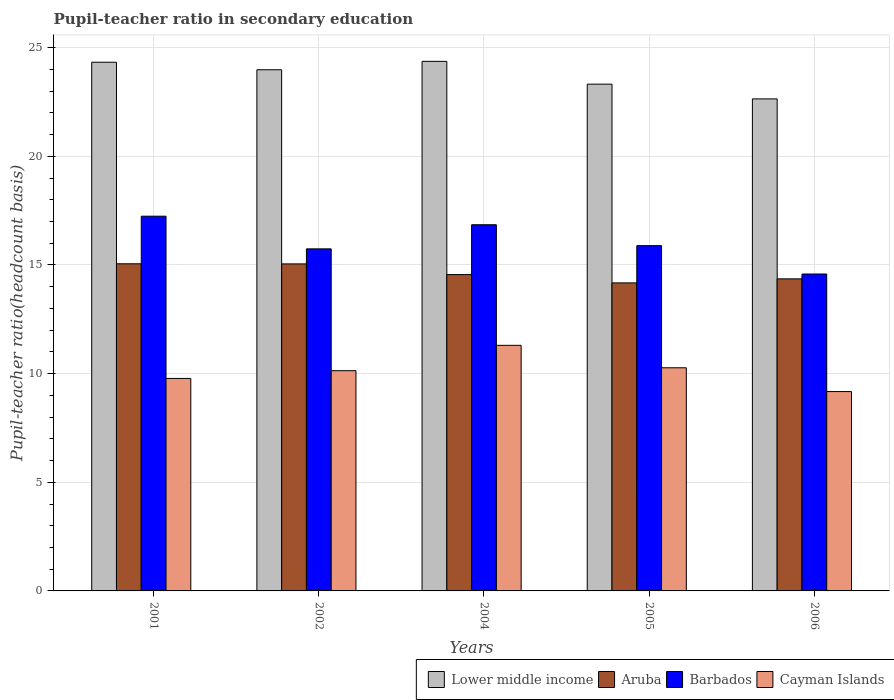How many groups of bars are there?
Keep it short and to the point. 5. Are the number of bars on each tick of the X-axis equal?
Offer a very short reply. Yes. How many bars are there on the 2nd tick from the left?
Make the answer very short. 4. What is the label of the 1st group of bars from the left?
Offer a very short reply. 2001. What is the pupil-teacher ratio in secondary education in Cayman Islands in 2006?
Keep it short and to the point. 9.17. Across all years, what is the maximum pupil-teacher ratio in secondary education in Cayman Islands?
Your response must be concise. 11.3. Across all years, what is the minimum pupil-teacher ratio in secondary education in Aruba?
Offer a very short reply. 14.18. In which year was the pupil-teacher ratio in secondary education in Cayman Islands minimum?
Offer a terse response. 2006. What is the total pupil-teacher ratio in secondary education in Aruba in the graph?
Make the answer very short. 73.2. What is the difference between the pupil-teacher ratio in secondary education in Barbados in 2001 and that in 2006?
Give a very brief answer. 2.66. What is the difference between the pupil-teacher ratio in secondary education in Lower middle income in 2005 and the pupil-teacher ratio in secondary education in Barbados in 2001?
Provide a succinct answer. 6.08. What is the average pupil-teacher ratio in secondary education in Aruba per year?
Your answer should be very brief. 14.64. In the year 2001, what is the difference between the pupil-teacher ratio in secondary education in Cayman Islands and pupil-teacher ratio in secondary education in Barbados?
Ensure brevity in your answer.  -7.47. In how many years, is the pupil-teacher ratio in secondary education in Cayman Islands greater than 15?
Your answer should be very brief. 0. What is the ratio of the pupil-teacher ratio in secondary education in Aruba in 2002 to that in 2006?
Offer a terse response. 1.05. Is the pupil-teacher ratio in secondary education in Aruba in 2004 less than that in 2005?
Ensure brevity in your answer.  No. Is the difference between the pupil-teacher ratio in secondary education in Cayman Islands in 2001 and 2004 greater than the difference between the pupil-teacher ratio in secondary education in Barbados in 2001 and 2004?
Keep it short and to the point. No. What is the difference between the highest and the second highest pupil-teacher ratio in secondary education in Barbados?
Make the answer very short. 0.39. What is the difference between the highest and the lowest pupil-teacher ratio in secondary education in Aruba?
Provide a short and direct response. 0.88. In how many years, is the pupil-teacher ratio in secondary education in Barbados greater than the average pupil-teacher ratio in secondary education in Barbados taken over all years?
Give a very brief answer. 2. Is the sum of the pupil-teacher ratio in secondary education in Aruba in 2001 and 2002 greater than the maximum pupil-teacher ratio in secondary education in Cayman Islands across all years?
Ensure brevity in your answer.  Yes. Is it the case that in every year, the sum of the pupil-teacher ratio in secondary education in Aruba and pupil-teacher ratio in secondary education in Cayman Islands is greater than the sum of pupil-teacher ratio in secondary education in Lower middle income and pupil-teacher ratio in secondary education in Barbados?
Your answer should be compact. No. What does the 3rd bar from the left in 2002 represents?
Ensure brevity in your answer.  Barbados. What does the 3rd bar from the right in 2001 represents?
Make the answer very short. Aruba. Is it the case that in every year, the sum of the pupil-teacher ratio in secondary education in Lower middle income and pupil-teacher ratio in secondary education in Cayman Islands is greater than the pupil-teacher ratio in secondary education in Aruba?
Your response must be concise. Yes. Are all the bars in the graph horizontal?
Your answer should be very brief. No. What is the difference between two consecutive major ticks on the Y-axis?
Offer a terse response. 5. Does the graph contain any zero values?
Provide a succinct answer. No. Does the graph contain grids?
Offer a very short reply. Yes. How many legend labels are there?
Make the answer very short. 4. What is the title of the graph?
Your answer should be very brief. Pupil-teacher ratio in secondary education. What is the label or title of the Y-axis?
Make the answer very short. Pupil-teacher ratio(headcount basis). What is the Pupil-teacher ratio(headcount basis) in Lower middle income in 2001?
Your answer should be compact. 24.33. What is the Pupil-teacher ratio(headcount basis) of Aruba in 2001?
Keep it short and to the point. 15.05. What is the Pupil-teacher ratio(headcount basis) of Barbados in 2001?
Provide a short and direct response. 17.24. What is the Pupil-teacher ratio(headcount basis) in Cayman Islands in 2001?
Offer a very short reply. 9.78. What is the Pupil-teacher ratio(headcount basis) in Lower middle income in 2002?
Provide a short and direct response. 23.98. What is the Pupil-teacher ratio(headcount basis) of Aruba in 2002?
Give a very brief answer. 15.05. What is the Pupil-teacher ratio(headcount basis) in Barbados in 2002?
Give a very brief answer. 15.74. What is the Pupil-teacher ratio(headcount basis) in Cayman Islands in 2002?
Give a very brief answer. 10.13. What is the Pupil-teacher ratio(headcount basis) of Lower middle income in 2004?
Offer a terse response. 24.37. What is the Pupil-teacher ratio(headcount basis) of Aruba in 2004?
Your answer should be very brief. 14.56. What is the Pupil-teacher ratio(headcount basis) in Barbados in 2004?
Ensure brevity in your answer.  16.85. What is the Pupil-teacher ratio(headcount basis) of Cayman Islands in 2004?
Your response must be concise. 11.3. What is the Pupil-teacher ratio(headcount basis) of Lower middle income in 2005?
Keep it short and to the point. 23.32. What is the Pupil-teacher ratio(headcount basis) of Aruba in 2005?
Give a very brief answer. 14.18. What is the Pupil-teacher ratio(headcount basis) of Barbados in 2005?
Your answer should be very brief. 15.89. What is the Pupil-teacher ratio(headcount basis) of Cayman Islands in 2005?
Provide a succinct answer. 10.27. What is the Pupil-teacher ratio(headcount basis) of Lower middle income in 2006?
Offer a terse response. 22.64. What is the Pupil-teacher ratio(headcount basis) of Aruba in 2006?
Your answer should be compact. 14.36. What is the Pupil-teacher ratio(headcount basis) in Barbados in 2006?
Give a very brief answer. 14.58. What is the Pupil-teacher ratio(headcount basis) in Cayman Islands in 2006?
Provide a short and direct response. 9.17. Across all years, what is the maximum Pupil-teacher ratio(headcount basis) in Lower middle income?
Your answer should be very brief. 24.37. Across all years, what is the maximum Pupil-teacher ratio(headcount basis) in Aruba?
Your answer should be compact. 15.05. Across all years, what is the maximum Pupil-teacher ratio(headcount basis) of Barbados?
Make the answer very short. 17.24. Across all years, what is the maximum Pupil-teacher ratio(headcount basis) of Cayman Islands?
Ensure brevity in your answer.  11.3. Across all years, what is the minimum Pupil-teacher ratio(headcount basis) in Lower middle income?
Offer a very short reply. 22.64. Across all years, what is the minimum Pupil-teacher ratio(headcount basis) of Aruba?
Provide a succinct answer. 14.18. Across all years, what is the minimum Pupil-teacher ratio(headcount basis) in Barbados?
Offer a terse response. 14.58. Across all years, what is the minimum Pupil-teacher ratio(headcount basis) of Cayman Islands?
Make the answer very short. 9.17. What is the total Pupil-teacher ratio(headcount basis) of Lower middle income in the graph?
Provide a succinct answer. 118.65. What is the total Pupil-teacher ratio(headcount basis) in Aruba in the graph?
Ensure brevity in your answer.  73.2. What is the total Pupil-teacher ratio(headcount basis) of Barbados in the graph?
Provide a short and direct response. 80.31. What is the total Pupil-teacher ratio(headcount basis) in Cayman Islands in the graph?
Provide a succinct answer. 50.66. What is the difference between the Pupil-teacher ratio(headcount basis) in Lower middle income in 2001 and that in 2002?
Give a very brief answer. 0.35. What is the difference between the Pupil-teacher ratio(headcount basis) of Aruba in 2001 and that in 2002?
Offer a very short reply. 0. What is the difference between the Pupil-teacher ratio(headcount basis) in Barbados in 2001 and that in 2002?
Make the answer very short. 1.5. What is the difference between the Pupil-teacher ratio(headcount basis) of Cayman Islands in 2001 and that in 2002?
Your response must be concise. -0.36. What is the difference between the Pupil-teacher ratio(headcount basis) in Lower middle income in 2001 and that in 2004?
Your response must be concise. -0.04. What is the difference between the Pupil-teacher ratio(headcount basis) in Aruba in 2001 and that in 2004?
Provide a succinct answer. 0.5. What is the difference between the Pupil-teacher ratio(headcount basis) of Barbados in 2001 and that in 2004?
Your answer should be very brief. 0.39. What is the difference between the Pupil-teacher ratio(headcount basis) in Cayman Islands in 2001 and that in 2004?
Keep it short and to the point. -1.52. What is the difference between the Pupil-teacher ratio(headcount basis) of Lower middle income in 2001 and that in 2005?
Make the answer very short. 1.01. What is the difference between the Pupil-teacher ratio(headcount basis) in Aruba in 2001 and that in 2005?
Your response must be concise. 0.88. What is the difference between the Pupil-teacher ratio(headcount basis) of Barbados in 2001 and that in 2005?
Your response must be concise. 1.36. What is the difference between the Pupil-teacher ratio(headcount basis) of Cayman Islands in 2001 and that in 2005?
Provide a succinct answer. -0.49. What is the difference between the Pupil-teacher ratio(headcount basis) in Lower middle income in 2001 and that in 2006?
Your response must be concise. 1.69. What is the difference between the Pupil-teacher ratio(headcount basis) in Aruba in 2001 and that in 2006?
Give a very brief answer. 0.69. What is the difference between the Pupil-teacher ratio(headcount basis) in Barbados in 2001 and that in 2006?
Your answer should be very brief. 2.66. What is the difference between the Pupil-teacher ratio(headcount basis) in Cayman Islands in 2001 and that in 2006?
Give a very brief answer. 0.6. What is the difference between the Pupil-teacher ratio(headcount basis) of Lower middle income in 2002 and that in 2004?
Ensure brevity in your answer.  -0.39. What is the difference between the Pupil-teacher ratio(headcount basis) in Aruba in 2002 and that in 2004?
Keep it short and to the point. 0.49. What is the difference between the Pupil-teacher ratio(headcount basis) in Barbados in 2002 and that in 2004?
Make the answer very short. -1.11. What is the difference between the Pupil-teacher ratio(headcount basis) in Cayman Islands in 2002 and that in 2004?
Your answer should be very brief. -1.17. What is the difference between the Pupil-teacher ratio(headcount basis) of Lower middle income in 2002 and that in 2005?
Your answer should be compact. 0.66. What is the difference between the Pupil-teacher ratio(headcount basis) of Aruba in 2002 and that in 2005?
Offer a very short reply. 0.87. What is the difference between the Pupil-teacher ratio(headcount basis) of Barbados in 2002 and that in 2005?
Ensure brevity in your answer.  -0.15. What is the difference between the Pupil-teacher ratio(headcount basis) in Cayman Islands in 2002 and that in 2005?
Make the answer very short. -0.13. What is the difference between the Pupil-teacher ratio(headcount basis) of Lower middle income in 2002 and that in 2006?
Your answer should be very brief. 1.34. What is the difference between the Pupil-teacher ratio(headcount basis) of Aruba in 2002 and that in 2006?
Your answer should be very brief. 0.69. What is the difference between the Pupil-teacher ratio(headcount basis) of Barbados in 2002 and that in 2006?
Offer a very short reply. 1.16. What is the difference between the Pupil-teacher ratio(headcount basis) in Cayman Islands in 2002 and that in 2006?
Give a very brief answer. 0.96. What is the difference between the Pupil-teacher ratio(headcount basis) in Lower middle income in 2004 and that in 2005?
Your response must be concise. 1.05. What is the difference between the Pupil-teacher ratio(headcount basis) of Aruba in 2004 and that in 2005?
Keep it short and to the point. 0.38. What is the difference between the Pupil-teacher ratio(headcount basis) of Barbados in 2004 and that in 2005?
Offer a very short reply. 0.96. What is the difference between the Pupil-teacher ratio(headcount basis) in Cayman Islands in 2004 and that in 2005?
Your response must be concise. 1.03. What is the difference between the Pupil-teacher ratio(headcount basis) of Lower middle income in 2004 and that in 2006?
Give a very brief answer. 1.73. What is the difference between the Pupil-teacher ratio(headcount basis) of Aruba in 2004 and that in 2006?
Provide a succinct answer. 0.2. What is the difference between the Pupil-teacher ratio(headcount basis) of Barbados in 2004 and that in 2006?
Give a very brief answer. 2.27. What is the difference between the Pupil-teacher ratio(headcount basis) in Cayman Islands in 2004 and that in 2006?
Your response must be concise. 2.13. What is the difference between the Pupil-teacher ratio(headcount basis) in Lower middle income in 2005 and that in 2006?
Offer a terse response. 0.68. What is the difference between the Pupil-teacher ratio(headcount basis) in Aruba in 2005 and that in 2006?
Make the answer very short. -0.19. What is the difference between the Pupil-teacher ratio(headcount basis) of Barbados in 2005 and that in 2006?
Offer a terse response. 1.3. What is the difference between the Pupil-teacher ratio(headcount basis) of Cayman Islands in 2005 and that in 2006?
Give a very brief answer. 1.09. What is the difference between the Pupil-teacher ratio(headcount basis) in Lower middle income in 2001 and the Pupil-teacher ratio(headcount basis) in Aruba in 2002?
Provide a short and direct response. 9.28. What is the difference between the Pupil-teacher ratio(headcount basis) of Lower middle income in 2001 and the Pupil-teacher ratio(headcount basis) of Barbados in 2002?
Your response must be concise. 8.59. What is the difference between the Pupil-teacher ratio(headcount basis) in Lower middle income in 2001 and the Pupil-teacher ratio(headcount basis) in Cayman Islands in 2002?
Provide a short and direct response. 14.2. What is the difference between the Pupil-teacher ratio(headcount basis) in Aruba in 2001 and the Pupil-teacher ratio(headcount basis) in Barbados in 2002?
Offer a very short reply. -0.69. What is the difference between the Pupil-teacher ratio(headcount basis) of Aruba in 2001 and the Pupil-teacher ratio(headcount basis) of Cayman Islands in 2002?
Keep it short and to the point. 4.92. What is the difference between the Pupil-teacher ratio(headcount basis) in Barbados in 2001 and the Pupil-teacher ratio(headcount basis) in Cayman Islands in 2002?
Ensure brevity in your answer.  7.11. What is the difference between the Pupil-teacher ratio(headcount basis) in Lower middle income in 2001 and the Pupil-teacher ratio(headcount basis) in Aruba in 2004?
Offer a very short reply. 9.77. What is the difference between the Pupil-teacher ratio(headcount basis) of Lower middle income in 2001 and the Pupil-teacher ratio(headcount basis) of Barbados in 2004?
Your response must be concise. 7.48. What is the difference between the Pupil-teacher ratio(headcount basis) of Lower middle income in 2001 and the Pupil-teacher ratio(headcount basis) of Cayman Islands in 2004?
Your answer should be compact. 13.03. What is the difference between the Pupil-teacher ratio(headcount basis) of Aruba in 2001 and the Pupil-teacher ratio(headcount basis) of Barbados in 2004?
Offer a terse response. -1.8. What is the difference between the Pupil-teacher ratio(headcount basis) in Aruba in 2001 and the Pupil-teacher ratio(headcount basis) in Cayman Islands in 2004?
Provide a succinct answer. 3.75. What is the difference between the Pupil-teacher ratio(headcount basis) of Barbados in 2001 and the Pupil-teacher ratio(headcount basis) of Cayman Islands in 2004?
Your answer should be very brief. 5.94. What is the difference between the Pupil-teacher ratio(headcount basis) of Lower middle income in 2001 and the Pupil-teacher ratio(headcount basis) of Aruba in 2005?
Offer a terse response. 10.15. What is the difference between the Pupil-teacher ratio(headcount basis) of Lower middle income in 2001 and the Pupil-teacher ratio(headcount basis) of Barbados in 2005?
Ensure brevity in your answer.  8.44. What is the difference between the Pupil-teacher ratio(headcount basis) of Lower middle income in 2001 and the Pupil-teacher ratio(headcount basis) of Cayman Islands in 2005?
Your response must be concise. 14.06. What is the difference between the Pupil-teacher ratio(headcount basis) in Aruba in 2001 and the Pupil-teacher ratio(headcount basis) in Barbados in 2005?
Provide a short and direct response. -0.83. What is the difference between the Pupil-teacher ratio(headcount basis) in Aruba in 2001 and the Pupil-teacher ratio(headcount basis) in Cayman Islands in 2005?
Offer a very short reply. 4.78. What is the difference between the Pupil-teacher ratio(headcount basis) in Barbados in 2001 and the Pupil-teacher ratio(headcount basis) in Cayman Islands in 2005?
Your response must be concise. 6.98. What is the difference between the Pupil-teacher ratio(headcount basis) of Lower middle income in 2001 and the Pupil-teacher ratio(headcount basis) of Aruba in 2006?
Offer a terse response. 9.97. What is the difference between the Pupil-teacher ratio(headcount basis) of Lower middle income in 2001 and the Pupil-teacher ratio(headcount basis) of Barbados in 2006?
Ensure brevity in your answer.  9.75. What is the difference between the Pupil-teacher ratio(headcount basis) in Lower middle income in 2001 and the Pupil-teacher ratio(headcount basis) in Cayman Islands in 2006?
Provide a succinct answer. 15.16. What is the difference between the Pupil-teacher ratio(headcount basis) of Aruba in 2001 and the Pupil-teacher ratio(headcount basis) of Barbados in 2006?
Keep it short and to the point. 0.47. What is the difference between the Pupil-teacher ratio(headcount basis) of Aruba in 2001 and the Pupil-teacher ratio(headcount basis) of Cayman Islands in 2006?
Make the answer very short. 5.88. What is the difference between the Pupil-teacher ratio(headcount basis) in Barbados in 2001 and the Pupil-teacher ratio(headcount basis) in Cayman Islands in 2006?
Provide a succinct answer. 8.07. What is the difference between the Pupil-teacher ratio(headcount basis) of Lower middle income in 2002 and the Pupil-teacher ratio(headcount basis) of Aruba in 2004?
Give a very brief answer. 9.43. What is the difference between the Pupil-teacher ratio(headcount basis) in Lower middle income in 2002 and the Pupil-teacher ratio(headcount basis) in Barbados in 2004?
Your answer should be compact. 7.13. What is the difference between the Pupil-teacher ratio(headcount basis) in Lower middle income in 2002 and the Pupil-teacher ratio(headcount basis) in Cayman Islands in 2004?
Provide a short and direct response. 12.68. What is the difference between the Pupil-teacher ratio(headcount basis) of Aruba in 2002 and the Pupil-teacher ratio(headcount basis) of Barbados in 2004?
Give a very brief answer. -1.8. What is the difference between the Pupil-teacher ratio(headcount basis) in Aruba in 2002 and the Pupil-teacher ratio(headcount basis) in Cayman Islands in 2004?
Your response must be concise. 3.75. What is the difference between the Pupil-teacher ratio(headcount basis) of Barbados in 2002 and the Pupil-teacher ratio(headcount basis) of Cayman Islands in 2004?
Ensure brevity in your answer.  4.44. What is the difference between the Pupil-teacher ratio(headcount basis) of Lower middle income in 2002 and the Pupil-teacher ratio(headcount basis) of Aruba in 2005?
Your response must be concise. 9.81. What is the difference between the Pupil-teacher ratio(headcount basis) in Lower middle income in 2002 and the Pupil-teacher ratio(headcount basis) in Barbados in 2005?
Your response must be concise. 8.09. What is the difference between the Pupil-teacher ratio(headcount basis) in Lower middle income in 2002 and the Pupil-teacher ratio(headcount basis) in Cayman Islands in 2005?
Provide a succinct answer. 13.71. What is the difference between the Pupil-teacher ratio(headcount basis) of Aruba in 2002 and the Pupil-teacher ratio(headcount basis) of Barbados in 2005?
Your answer should be very brief. -0.84. What is the difference between the Pupil-teacher ratio(headcount basis) of Aruba in 2002 and the Pupil-teacher ratio(headcount basis) of Cayman Islands in 2005?
Offer a terse response. 4.78. What is the difference between the Pupil-teacher ratio(headcount basis) of Barbados in 2002 and the Pupil-teacher ratio(headcount basis) of Cayman Islands in 2005?
Keep it short and to the point. 5.47. What is the difference between the Pupil-teacher ratio(headcount basis) in Lower middle income in 2002 and the Pupil-teacher ratio(headcount basis) in Aruba in 2006?
Your response must be concise. 9.62. What is the difference between the Pupil-teacher ratio(headcount basis) of Lower middle income in 2002 and the Pupil-teacher ratio(headcount basis) of Barbados in 2006?
Offer a very short reply. 9.4. What is the difference between the Pupil-teacher ratio(headcount basis) of Lower middle income in 2002 and the Pupil-teacher ratio(headcount basis) of Cayman Islands in 2006?
Your response must be concise. 14.81. What is the difference between the Pupil-teacher ratio(headcount basis) in Aruba in 2002 and the Pupil-teacher ratio(headcount basis) in Barbados in 2006?
Keep it short and to the point. 0.47. What is the difference between the Pupil-teacher ratio(headcount basis) in Aruba in 2002 and the Pupil-teacher ratio(headcount basis) in Cayman Islands in 2006?
Your answer should be compact. 5.87. What is the difference between the Pupil-teacher ratio(headcount basis) in Barbados in 2002 and the Pupil-teacher ratio(headcount basis) in Cayman Islands in 2006?
Your response must be concise. 6.57. What is the difference between the Pupil-teacher ratio(headcount basis) of Lower middle income in 2004 and the Pupil-teacher ratio(headcount basis) of Aruba in 2005?
Ensure brevity in your answer.  10.19. What is the difference between the Pupil-teacher ratio(headcount basis) in Lower middle income in 2004 and the Pupil-teacher ratio(headcount basis) in Barbados in 2005?
Keep it short and to the point. 8.48. What is the difference between the Pupil-teacher ratio(headcount basis) in Lower middle income in 2004 and the Pupil-teacher ratio(headcount basis) in Cayman Islands in 2005?
Give a very brief answer. 14.1. What is the difference between the Pupil-teacher ratio(headcount basis) of Aruba in 2004 and the Pupil-teacher ratio(headcount basis) of Barbados in 2005?
Provide a succinct answer. -1.33. What is the difference between the Pupil-teacher ratio(headcount basis) in Aruba in 2004 and the Pupil-teacher ratio(headcount basis) in Cayman Islands in 2005?
Keep it short and to the point. 4.29. What is the difference between the Pupil-teacher ratio(headcount basis) in Barbados in 2004 and the Pupil-teacher ratio(headcount basis) in Cayman Islands in 2005?
Provide a succinct answer. 6.58. What is the difference between the Pupil-teacher ratio(headcount basis) in Lower middle income in 2004 and the Pupil-teacher ratio(headcount basis) in Aruba in 2006?
Your answer should be very brief. 10.01. What is the difference between the Pupil-teacher ratio(headcount basis) of Lower middle income in 2004 and the Pupil-teacher ratio(headcount basis) of Barbados in 2006?
Provide a short and direct response. 9.79. What is the difference between the Pupil-teacher ratio(headcount basis) in Lower middle income in 2004 and the Pupil-teacher ratio(headcount basis) in Cayman Islands in 2006?
Offer a very short reply. 15.2. What is the difference between the Pupil-teacher ratio(headcount basis) of Aruba in 2004 and the Pupil-teacher ratio(headcount basis) of Barbados in 2006?
Your response must be concise. -0.03. What is the difference between the Pupil-teacher ratio(headcount basis) in Aruba in 2004 and the Pupil-teacher ratio(headcount basis) in Cayman Islands in 2006?
Offer a terse response. 5.38. What is the difference between the Pupil-teacher ratio(headcount basis) in Barbados in 2004 and the Pupil-teacher ratio(headcount basis) in Cayman Islands in 2006?
Ensure brevity in your answer.  7.68. What is the difference between the Pupil-teacher ratio(headcount basis) in Lower middle income in 2005 and the Pupil-teacher ratio(headcount basis) in Aruba in 2006?
Your answer should be very brief. 8.96. What is the difference between the Pupil-teacher ratio(headcount basis) in Lower middle income in 2005 and the Pupil-teacher ratio(headcount basis) in Barbados in 2006?
Offer a terse response. 8.74. What is the difference between the Pupil-teacher ratio(headcount basis) in Lower middle income in 2005 and the Pupil-teacher ratio(headcount basis) in Cayman Islands in 2006?
Provide a short and direct response. 14.15. What is the difference between the Pupil-teacher ratio(headcount basis) in Aruba in 2005 and the Pupil-teacher ratio(headcount basis) in Barbados in 2006?
Your answer should be very brief. -0.41. What is the difference between the Pupil-teacher ratio(headcount basis) of Aruba in 2005 and the Pupil-teacher ratio(headcount basis) of Cayman Islands in 2006?
Provide a short and direct response. 5. What is the difference between the Pupil-teacher ratio(headcount basis) in Barbados in 2005 and the Pupil-teacher ratio(headcount basis) in Cayman Islands in 2006?
Provide a succinct answer. 6.71. What is the average Pupil-teacher ratio(headcount basis) of Lower middle income per year?
Offer a terse response. 23.73. What is the average Pupil-teacher ratio(headcount basis) in Aruba per year?
Give a very brief answer. 14.64. What is the average Pupil-teacher ratio(headcount basis) of Barbados per year?
Keep it short and to the point. 16.06. What is the average Pupil-teacher ratio(headcount basis) in Cayman Islands per year?
Provide a short and direct response. 10.13. In the year 2001, what is the difference between the Pupil-teacher ratio(headcount basis) in Lower middle income and Pupil-teacher ratio(headcount basis) in Aruba?
Provide a succinct answer. 9.28. In the year 2001, what is the difference between the Pupil-teacher ratio(headcount basis) in Lower middle income and Pupil-teacher ratio(headcount basis) in Barbados?
Provide a short and direct response. 7.08. In the year 2001, what is the difference between the Pupil-teacher ratio(headcount basis) in Lower middle income and Pupil-teacher ratio(headcount basis) in Cayman Islands?
Your response must be concise. 14.55. In the year 2001, what is the difference between the Pupil-teacher ratio(headcount basis) of Aruba and Pupil-teacher ratio(headcount basis) of Barbados?
Provide a succinct answer. -2.19. In the year 2001, what is the difference between the Pupil-teacher ratio(headcount basis) of Aruba and Pupil-teacher ratio(headcount basis) of Cayman Islands?
Give a very brief answer. 5.28. In the year 2001, what is the difference between the Pupil-teacher ratio(headcount basis) of Barbados and Pupil-teacher ratio(headcount basis) of Cayman Islands?
Offer a very short reply. 7.47. In the year 2002, what is the difference between the Pupil-teacher ratio(headcount basis) of Lower middle income and Pupil-teacher ratio(headcount basis) of Aruba?
Provide a succinct answer. 8.93. In the year 2002, what is the difference between the Pupil-teacher ratio(headcount basis) of Lower middle income and Pupil-teacher ratio(headcount basis) of Barbados?
Your answer should be compact. 8.24. In the year 2002, what is the difference between the Pupil-teacher ratio(headcount basis) in Lower middle income and Pupil-teacher ratio(headcount basis) in Cayman Islands?
Offer a terse response. 13.85. In the year 2002, what is the difference between the Pupil-teacher ratio(headcount basis) of Aruba and Pupil-teacher ratio(headcount basis) of Barbados?
Your answer should be very brief. -0.69. In the year 2002, what is the difference between the Pupil-teacher ratio(headcount basis) of Aruba and Pupil-teacher ratio(headcount basis) of Cayman Islands?
Offer a terse response. 4.91. In the year 2002, what is the difference between the Pupil-teacher ratio(headcount basis) in Barbados and Pupil-teacher ratio(headcount basis) in Cayman Islands?
Provide a short and direct response. 5.61. In the year 2004, what is the difference between the Pupil-teacher ratio(headcount basis) of Lower middle income and Pupil-teacher ratio(headcount basis) of Aruba?
Offer a terse response. 9.81. In the year 2004, what is the difference between the Pupil-teacher ratio(headcount basis) of Lower middle income and Pupil-teacher ratio(headcount basis) of Barbados?
Offer a very short reply. 7.52. In the year 2004, what is the difference between the Pupil-teacher ratio(headcount basis) in Lower middle income and Pupil-teacher ratio(headcount basis) in Cayman Islands?
Offer a terse response. 13.07. In the year 2004, what is the difference between the Pupil-teacher ratio(headcount basis) in Aruba and Pupil-teacher ratio(headcount basis) in Barbados?
Offer a very short reply. -2.29. In the year 2004, what is the difference between the Pupil-teacher ratio(headcount basis) of Aruba and Pupil-teacher ratio(headcount basis) of Cayman Islands?
Your answer should be compact. 3.26. In the year 2004, what is the difference between the Pupil-teacher ratio(headcount basis) of Barbados and Pupil-teacher ratio(headcount basis) of Cayman Islands?
Make the answer very short. 5.55. In the year 2005, what is the difference between the Pupil-teacher ratio(headcount basis) in Lower middle income and Pupil-teacher ratio(headcount basis) in Aruba?
Your response must be concise. 9.15. In the year 2005, what is the difference between the Pupil-teacher ratio(headcount basis) of Lower middle income and Pupil-teacher ratio(headcount basis) of Barbados?
Give a very brief answer. 7.43. In the year 2005, what is the difference between the Pupil-teacher ratio(headcount basis) in Lower middle income and Pupil-teacher ratio(headcount basis) in Cayman Islands?
Keep it short and to the point. 13.05. In the year 2005, what is the difference between the Pupil-teacher ratio(headcount basis) of Aruba and Pupil-teacher ratio(headcount basis) of Barbados?
Keep it short and to the point. -1.71. In the year 2005, what is the difference between the Pupil-teacher ratio(headcount basis) of Aruba and Pupil-teacher ratio(headcount basis) of Cayman Islands?
Provide a succinct answer. 3.91. In the year 2005, what is the difference between the Pupil-teacher ratio(headcount basis) in Barbados and Pupil-teacher ratio(headcount basis) in Cayman Islands?
Provide a succinct answer. 5.62. In the year 2006, what is the difference between the Pupil-teacher ratio(headcount basis) in Lower middle income and Pupil-teacher ratio(headcount basis) in Aruba?
Your response must be concise. 8.28. In the year 2006, what is the difference between the Pupil-teacher ratio(headcount basis) of Lower middle income and Pupil-teacher ratio(headcount basis) of Barbados?
Provide a short and direct response. 8.06. In the year 2006, what is the difference between the Pupil-teacher ratio(headcount basis) of Lower middle income and Pupil-teacher ratio(headcount basis) of Cayman Islands?
Your response must be concise. 13.47. In the year 2006, what is the difference between the Pupil-teacher ratio(headcount basis) of Aruba and Pupil-teacher ratio(headcount basis) of Barbados?
Keep it short and to the point. -0.22. In the year 2006, what is the difference between the Pupil-teacher ratio(headcount basis) of Aruba and Pupil-teacher ratio(headcount basis) of Cayman Islands?
Your answer should be very brief. 5.19. In the year 2006, what is the difference between the Pupil-teacher ratio(headcount basis) of Barbados and Pupil-teacher ratio(headcount basis) of Cayman Islands?
Provide a succinct answer. 5.41. What is the ratio of the Pupil-teacher ratio(headcount basis) of Lower middle income in 2001 to that in 2002?
Offer a very short reply. 1.01. What is the ratio of the Pupil-teacher ratio(headcount basis) of Aruba in 2001 to that in 2002?
Give a very brief answer. 1. What is the ratio of the Pupil-teacher ratio(headcount basis) in Barbados in 2001 to that in 2002?
Offer a very short reply. 1.1. What is the ratio of the Pupil-teacher ratio(headcount basis) in Cayman Islands in 2001 to that in 2002?
Offer a terse response. 0.96. What is the ratio of the Pupil-teacher ratio(headcount basis) of Lower middle income in 2001 to that in 2004?
Provide a succinct answer. 1. What is the ratio of the Pupil-teacher ratio(headcount basis) of Aruba in 2001 to that in 2004?
Keep it short and to the point. 1.03. What is the ratio of the Pupil-teacher ratio(headcount basis) in Barbados in 2001 to that in 2004?
Give a very brief answer. 1.02. What is the ratio of the Pupil-teacher ratio(headcount basis) in Cayman Islands in 2001 to that in 2004?
Keep it short and to the point. 0.87. What is the ratio of the Pupil-teacher ratio(headcount basis) of Lower middle income in 2001 to that in 2005?
Provide a succinct answer. 1.04. What is the ratio of the Pupil-teacher ratio(headcount basis) in Aruba in 2001 to that in 2005?
Provide a short and direct response. 1.06. What is the ratio of the Pupil-teacher ratio(headcount basis) of Barbados in 2001 to that in 2005?
Make the answer very short. 1.09. What is the ratio of the Pupil-teacher ratio(headcount basis) of Cayman Islands in 2001 to that in 2005?
Your answer should be compact. 0.95. What is the ratio of the Pupil-teacher ratio(headcount basis) of Lower middle income in 2001 to that in 2006?
Offer a very short reply. 1.07. What is the ratio of the Pupil-teacher ratio(headcount basis) in Aruba in 2001 to that in 2006?
Ensure brevity in your answer.  1.05. What is the ratio of the Pupil-teacher ratio(headcount basis) of Barbados in 2001 to that in 2006?
Give a very brief answer. 1.18. What is the ratio of the Pupil-teacher ratio(headcount basis) of Cayman Islands in 2001 to that in 2006?
Keep it short and to the point. 1.07. What is the ratio of the Pupil-teacher ratio(headcount basis) of Lower middle income in 2002 to that in 2004?
Your response must be concise. 0.98. What is the ratio of the Pupil-teacher ratio(headcount basis) in Aruba in 2002 to that in 2004?
Offer a terse response. 1.03. What is the ratio of the Pupil-teacher ratio(headcount basis) of Barbados in 2002 to that in 2004?
Offer a very short reply. 0.93. What is the ratio of the Pupil-teacher ratio(headcount basis) of Cayman Islands in 2002 to that in 2004?
Provide a succinct answer. 0.9. What is the ratio of the Pupil-teacher ratio(headcount basis) in Lower middle income in 2002 to that in 2005?
Keep it short and to the point. 1.03. What is the ratio of the Pupil-teacher ratio(headcount basis) of Aruba in 2002 to that in 2005?
Your response must be concise. 1.06. What is the ratio of the Pupil-teacher ratio(headcount basis) of Cayman Islands in 2002 to that in 2005?
Your answer should be compact. 0.99. What is the ratio of the Pupil-teacher ratio(headcount basis) of Lower middle income in 2002 to that in 2006?
Offer a very short reply. 1.06. What is the ratio of the Pupil-teacher ratio(headcount basis) in Aruba in 2002 to that in 2006?
Offer a very short reply. 1.05. What is the ratio of the Pupil-teacher ratio(headcount basis) of Barbados in 2002 to that in 2006?
Your response must be concise. 1.08. What is the ratio of the Pupil-teacher ratio(headcount basis) in Cayman Islands in 2002 to that in 2006?
Make the answer very short. 1.1. What is the ratio of the Pupil-teacher ratio(headcount basis) in Lower middle income in 2004 to that in 2005?
Your response must be concise. 1.04. What is the ratio of the Pupil-teacher ratio(headcount basis) of Aruba in 2004 to that in 2005?
Make the answer very short. 1.03. What is the ratio of the Pupil-teacher ratio(headcount basis) of Barbados in 2004 to that in 2005?
Your response must be concise. 1.06. What is the ratio of the Pupil-teacher ratio(headcount basis) of Cayman Islands in 2004 to that in 2005?
Your answer should be compact. 1.1. What is the ratio of the Pupil-teacher ratio(headcount basis) in Lower middle income in 2004 to that in 2006?
Offer a terse response. 1.08. What is the ratio of the Pupil-teacher ratio(headcount basis) of Aruba in 2004 to that in 2006?
Your answer should be very brief. 1.01. What is the ratio of the Pupil-teacher ratio(headcount basis) of Barbados in 2004 to that in 2006?
Offer a very short reply. 1.16. What is the ratio of the Pupil-teacher ratio(headcount basis) of Cayman Islands in 2004 to that in 2006?
Your answer should be compact. 1.23. What is the ratio of the Pupil-teacher ratio(headcount basis) in Lower middle income in 2005 to that in 2006?
Offer a terse response. 1.03. What is the ratio of the Pupil-teacher ratio(headcount basis) of Aruba in 2005 to that in 2006?
Offer a terse response. 0.99. What is the ratio of the Pupil-teacher ratio(headcount basis) in Barbados in 2005 to that in 2006?
Provide a short and direct response. 1.09. What is the ratio of the Pupil-teacher ratio(headcount basis) in Cayman Islands in 2005 to that in 2006?
Your answer should be very brief. 1.12. What is the difference between the highest and the second highest Pupil-teacher ratio(headcount basis) in Lower middle income?
Make the answer very short. 0.04. What is the difference between the highest and the second highest Pupil-teacher ratio(headcount basis) in Aruba?
Offer a very short reply. 0. What is the difference between the highest and the second highest Pupil-teacher ratio(headcount basis) in Barbados?
Provide a short and direct response. 0.39. What is the difference between the highest and the second highest Pupil-teacher ratio(headcount basis) of Cayman Islands?
Make the answer very short. 1.03. What is the difference between the highest and the lowest Pupil-teacher ratio(headcount basis) in Lower middle income?
Keep it short and to the point. 1.73. What is the difference between the highest and the lowest Pupil-teacher ratio(headcount basis) in Aruba?
Give a very brief answer. 0.88. What is the difference between the highest and the lowest Pupil-teacher ratio(headcount basis) of Barbados?
Your response must be concise. 2.66. What is the difference between the highest and the lowest Pupil-teacher ratio(headcount basis) in Cayman Islands?
Ensure brevity in your answer.  2.13. 